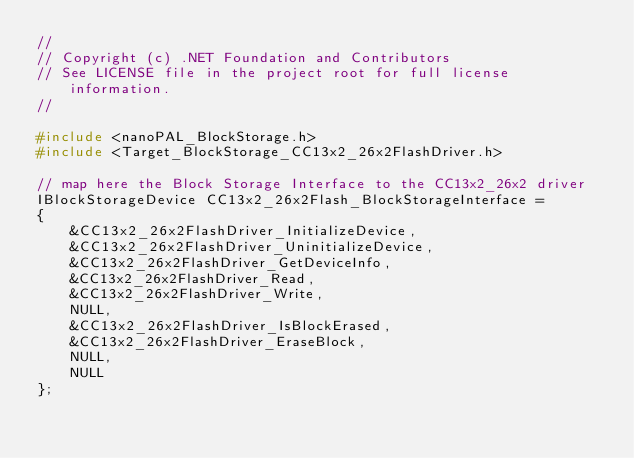<code> <loc_0><loc_0><loc_500><loc_500><_C_>//
// Copyright (c) .NET Foundation and Contributors
// See LICENSE file in the project root for full license information.
//

#include <nanoPAL_BlockStorage.h>
#include <Target_BlockStorage_CC13x2_26x2FlashDriver.h>

// map here the Block Storage Interface to the CC13x2_26x2 driver
IBlockStorageDevice CC13x2_26x2Flash_BlockStorageInterface =
{
    &CC13x2_26x2FlashDriver_InitializeDevice,
    &CC13x2_26x2FlashDriver_UninitializeDevice,
    &CC13x2_26x2FlashDriver_GetDeviceInfo,
    &CC13x2_26x2FlashDriver_Read,
    &CC13x2_26x2FlashDriver_Write,
    NULL,
    &CC13x2_26x2FlashDriver_IsBlockErased,
    &CC13x2_26x2FlashDriver_EraseBlock,
    NULL,
    NULL
};
</code> 